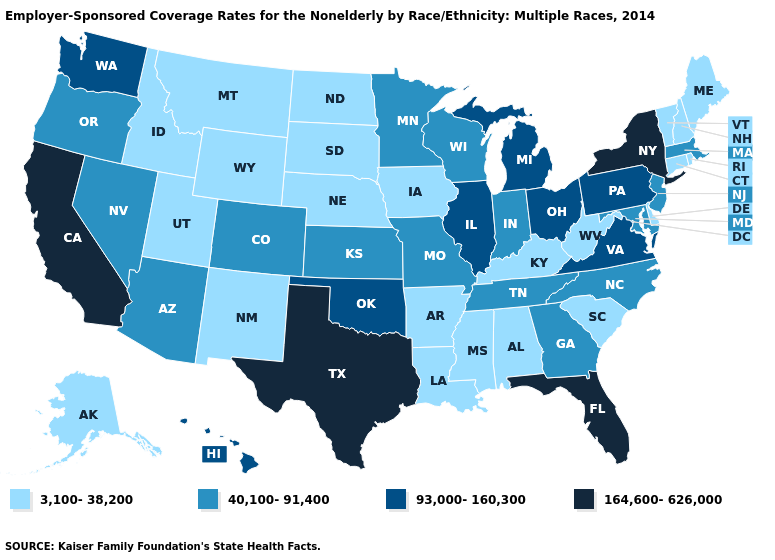What is the value of Illinois?
Be succinct. 93,000-160,300. What is the value of Arkansas?
Concise answer only. 3,100-38,200. What is the highest value in the West ?
Write a very short answer. 164,600-626,000. Does the map have missing data?
Be succinct. No. What is the highest value in the MidWest ?
Keep it brief. 93,000-160,300. What is the highest value in the West ?
Answer briefly. 164,600-626,000. Does Arkansas have the same value as Rhode Island?
Keep it brief. Yes. What is the value of Wyoming?
Answer briefly. 3,100-38,200. Does Nevada have the same value as Rhode Island?
Keep it brief. No. Name the states that have a value in the range 93,000-160,300?
Write a very short answer. Hawaii, Illinois, Michigan, Ohio, Oklahoma, Pennsylvania, Virginia, Washington. Does Louisiana have a lower value than Arkansas?
Be succinct. No. Name the states that have a value in the range 40,100-91,400?
Answer briefly. Arizona, Colorado, Georgia, Indiana, Kansas, Maryland, Massachusetts, Minnesota, Missouri, Nevada, New Jersey, North Carolina, Oregon, Tennessee, Wisconsin. Name the states that have a value in the range 164,600-626,000?
Write a very short answer. California, Florida, New York, Texas. What is the highest value in states that border Michigan?
Give a very brief answer. 93,000-160,300. 